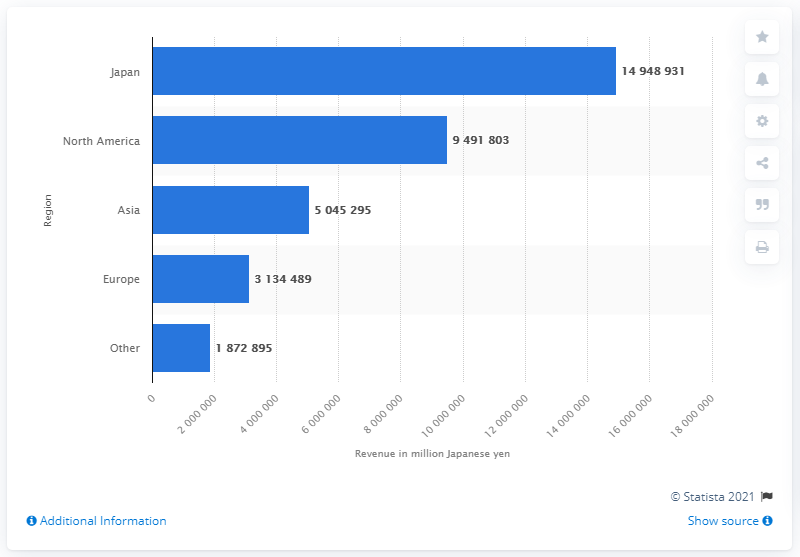Specify some key components in this picture. In 2021, North America was the second largest revenue generator for Toyota. According to the data for 2021, Japan was the country that generated the largest amount of revenue for Toyota. 